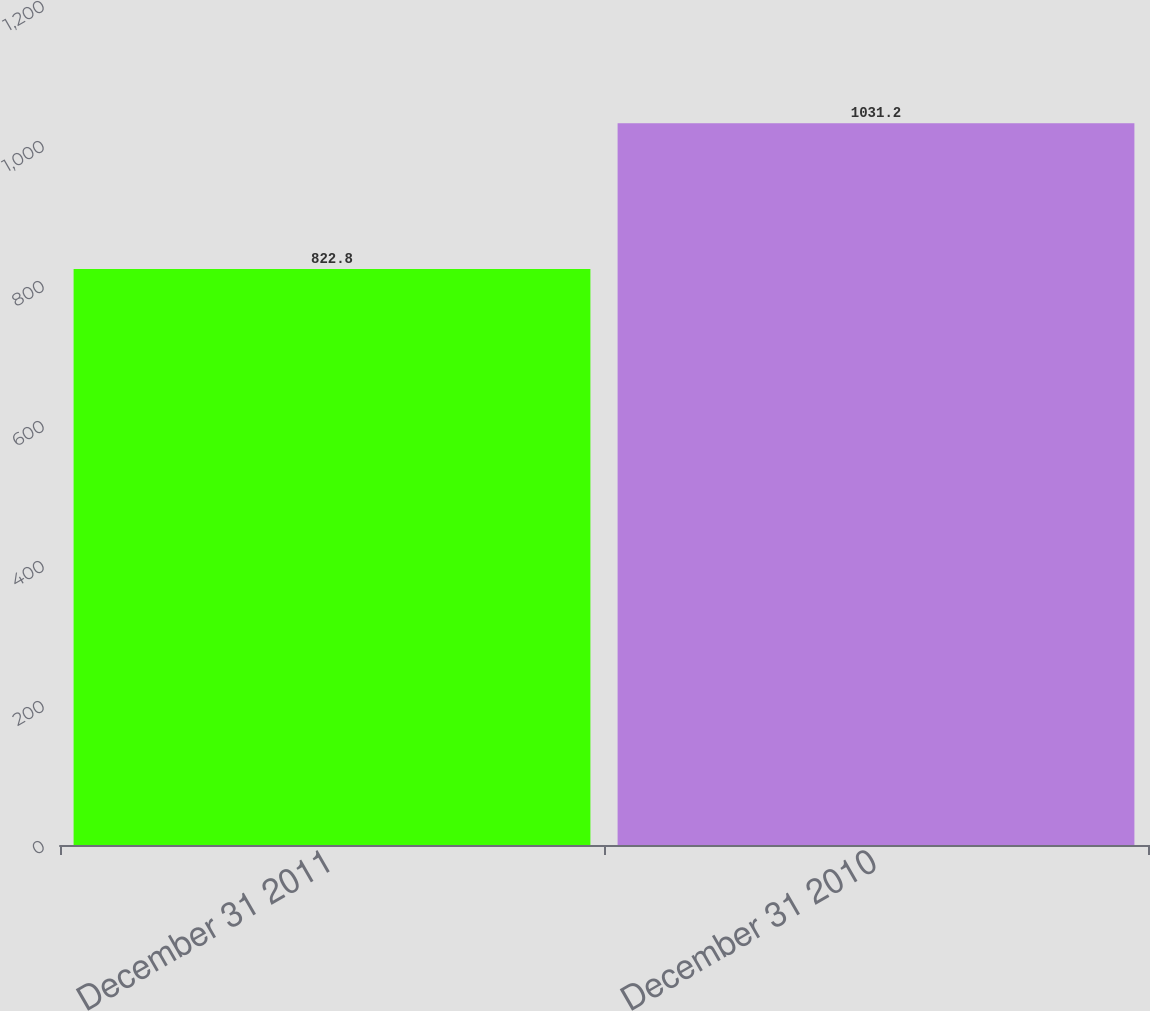Convert chart to OTSL. <chart><loc_0><loc_0><loc_500><loc_500><bar_chart><fcel>December 31 2011<fcel>December 31 2010<nl><fcel>822.8<fcel>1031.2<nl></chart> 